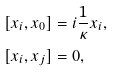<formula> <loc_0><loc_0><loc_500><loc_500>\left [ x _ { i } , x _ { 0 } \right ] & = i \frac { 1 } { \kappa } x _ { i } , \\ [ x _ { i } , x _ { j } ] & = 0 ,</formula> 